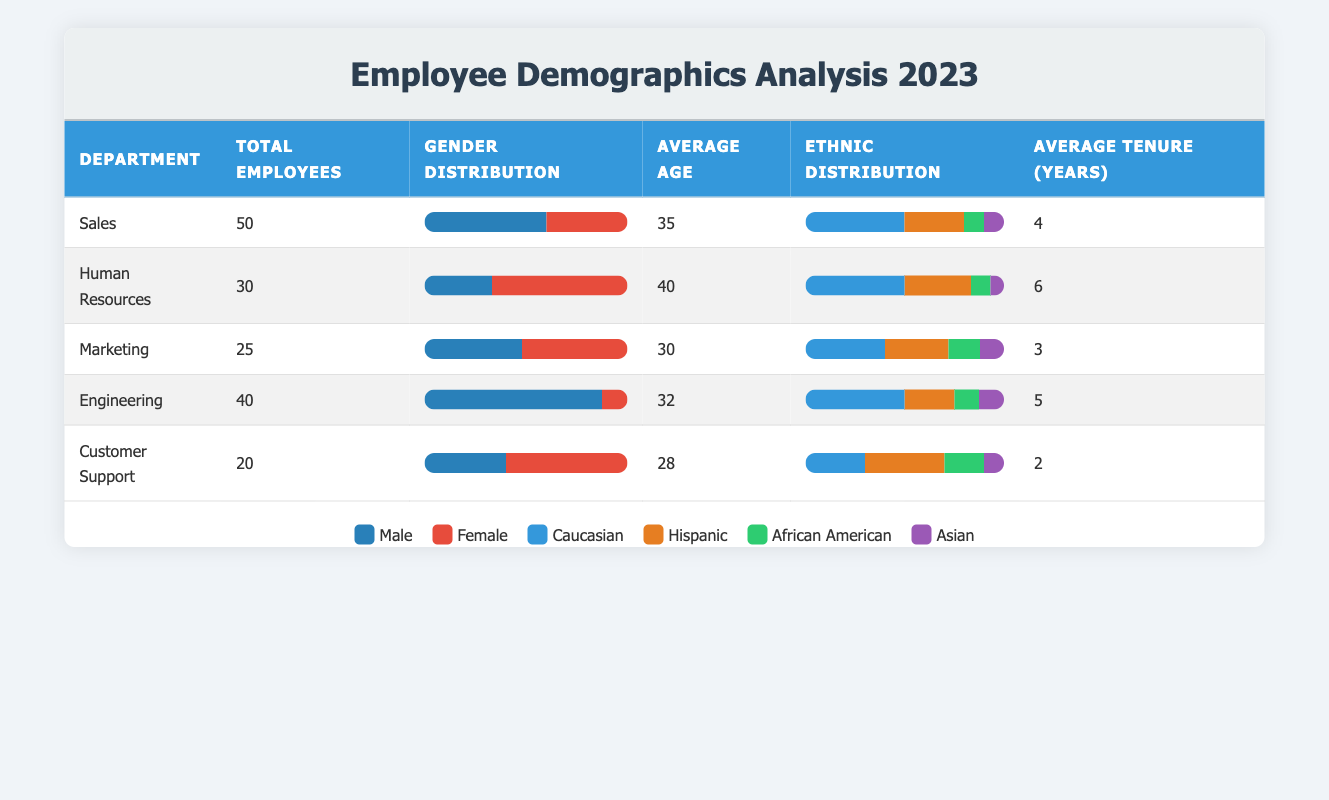What is the total number of employees in the Sales department? The information in the Sales department row shows that the total number of employees is 50.
Answer: 50 What percentage of employees in Human Resources are male? In the Human Resources department, there are 10 males out of a total of 30 employees. To find the percentage, (10 / 30) * 100 = 33.33%.
Answer: 33.33% Which department has the highest average age? By comparing the average ages listed in each department, Human Resources has an average age of 40, which is higher than the others.
Answer: Human Resources How many total employees are there across all departments? The total number of employees can be calculated by summing the employees across all departments: 50 (Sales) + 30 (HR) + 25 (Marketing) + 40 (Engineering) + 20 (Customer Support) = 165.
Answer: 165 Is the average tenure in Marketing greater than that in Customer Support? The average tenure for Marketing is 3 years, while for Customer Support it is 2 years. Since 3 is greater than 2, the statement is true.
Answer: Yes Which department has the lowest gender ratio for females? In Engineering, 5 out of 40 employees are female, which equates to a ratio of 12.5%. This is lower than the female ratios in other departments.
Answer: Engineering What is the average age of employees in the Engineering department? The average age of employees in the Engineering department is explicitly listed in the table as 32.
Answer: 32 How many total male employees are there in the company? To find the total male employees, sum the male counts from each department: 30 (Sales) + 10 (HR) + 12 (Marketing) + 35 (Engineering) + 8 (Customer Support) = 95.
Answer: 95 What is the ratio of Caucasian employees in the Marketing department compared to the total employees in that department? The number of Caucasian employees in Marketing is 10 out of a total of 25 employees. Therefore, the ratio is 10:25, which simplifies to 2:5.
Answer: 2:5 